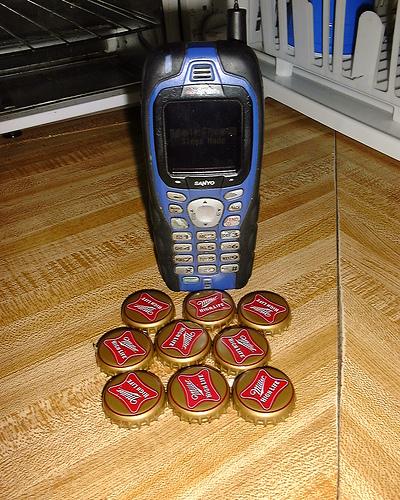How many bottle caps?
Keep it brief. 9. What kind of beverage are the bottle caps from?
Be succinct. Beer. Is that an old phone?
Write a very short answer. Yes. 